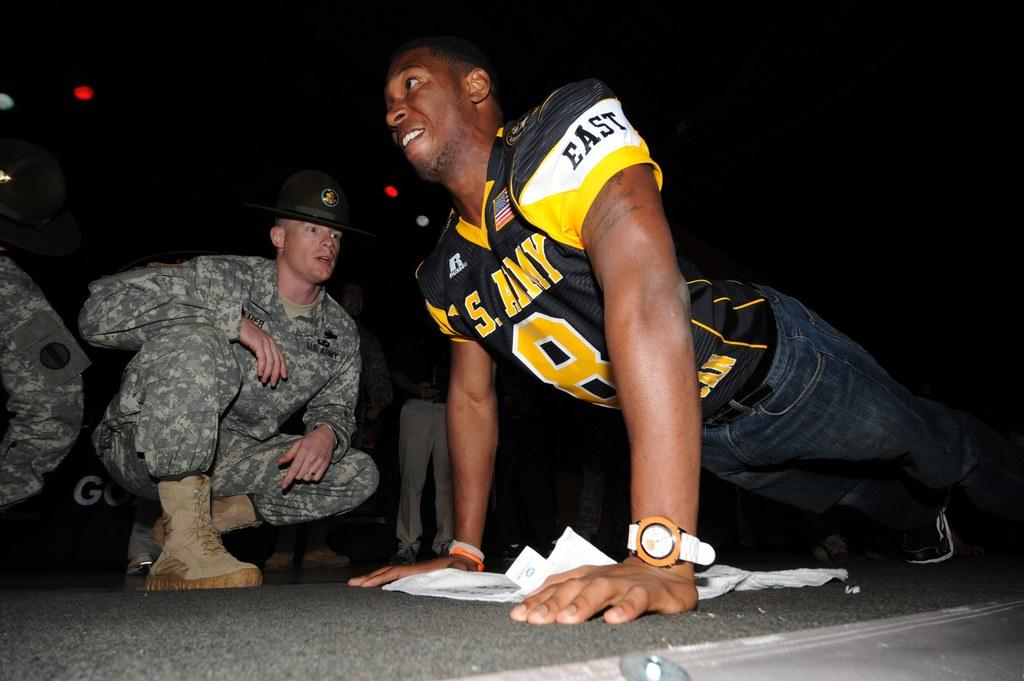<image>
Share a concise interpretation of the image provided. Two men, one of them doing a push up who has the word East on his sleeve. 